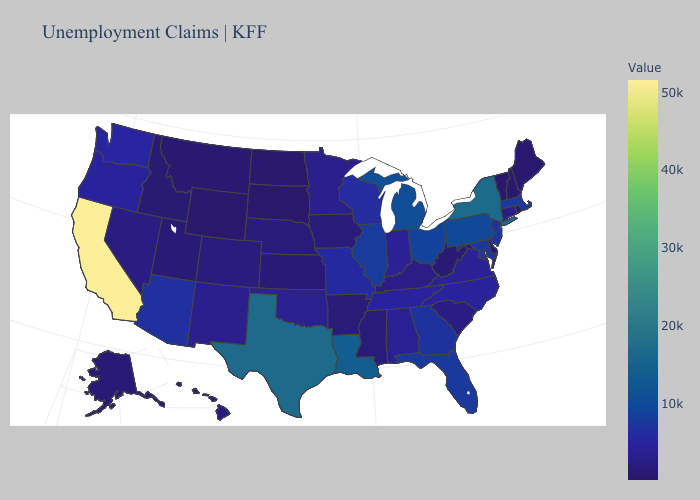Among the states that border Wisconsin , which have the lowest value?
Keep it brief. Iowa. Does West Virginia have a higher value than Florida?
Quick response, please. No. 